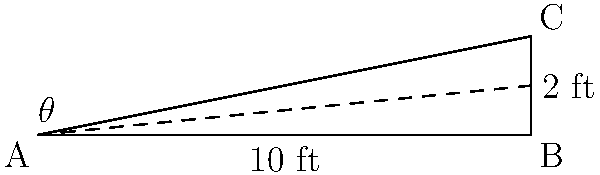A ramp is being designed for wheelchair accessibility in a geriatric care facility. The ramp has a length of 10 feet and rises to a height of 2 feet. What is the angle of inclination ($\theta$) of the ramp, and does it meet the recommended maximum slope of 1:12 (approximately 4.8 degrees) for wheelchair accessibility? Let's approach this step-by-step:

1) We can use the trigonometric function tangent to find the angle. In a right triangle:

   $\tan(\theta) = \frac{\text{opposite}}{\text{adjacent}} = \frac{\text{rise}}{\text{run}}$

2) We know the rise is 2 feet and the run is 10 feet. So:

   $\tan(\theta) = \frac{2}{10} = \frac{1}{5} = 0.2$

3) To find $\theta$, we need to use the inverse tangent (arctan or $\tan^{-1}$):

   $\theta = \tan^{-1}(0.2)$

4) Using a calculator or trigonometric tables:

   $\theta \approx 11.31$ degrees

5) To check if this meets the recommended maximum slope:
   - The recommended maximum is 1:12, which is equivalent to:
     $\tan^{-1}(\frac{1}{12}) \approx 4.76$ degrees

6) 11.31 degrees > 4.76 degrees

Therefore, the ramp's angle of inclination is approximately 11.31 degrees, which exceeds the recommended maximum of about 4.8 degrees for wheelchair accessibility.
Answer: $\theta \approx 11.31°$; No, it doesn't meet the recommended maximum slope. 